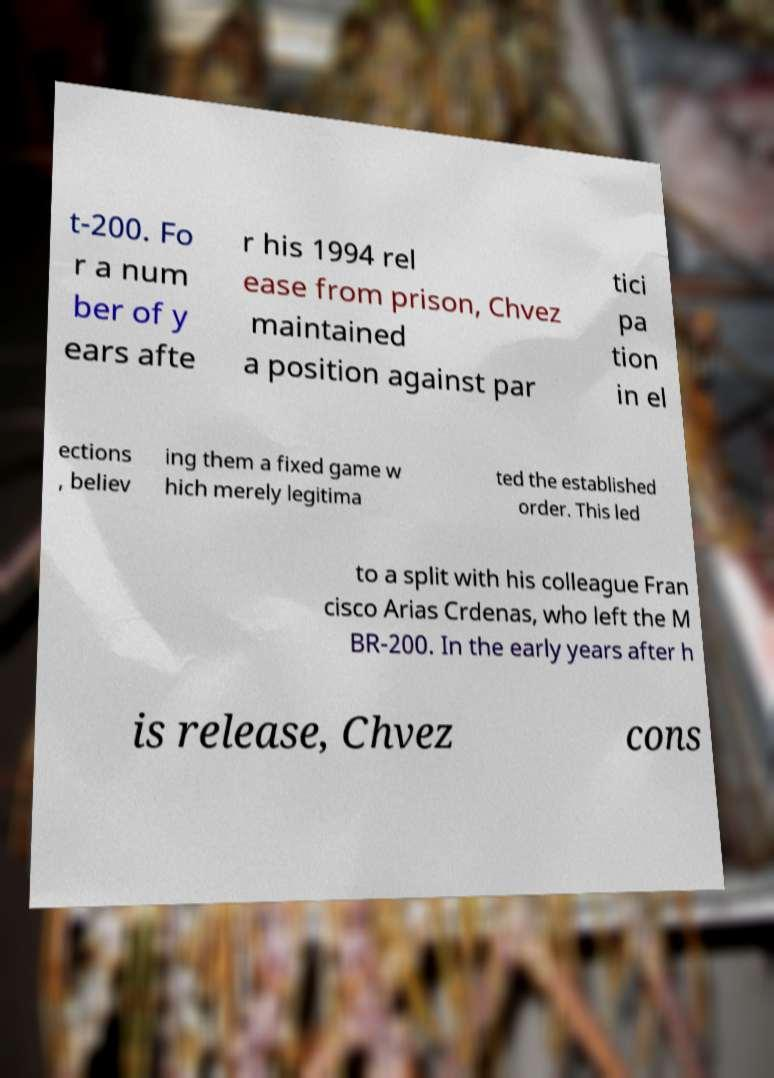Can you read and provide the text displayed in the image?This photo seems to have some interesting text. Can you extract and type it out for me? t-200. Fo r a num ber of y ears afte r his 1994 rel ease from prison, Chvez maintained a position against par tici pa tion in el ections , believ ing them a fixed game w hich merely legitima ted the established order. This led to a split with his colleague Fran cisco Arias Crdenas, who left the M BR-200. In the early years after h is release, Chvez cons 